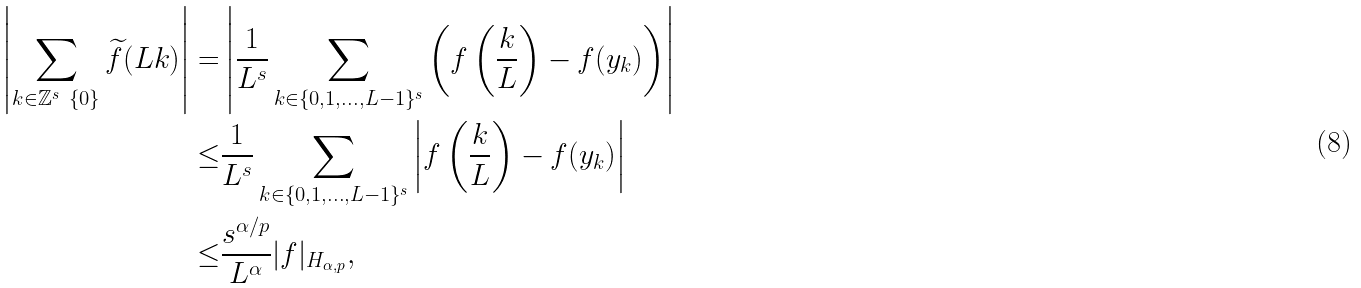<formula> <loc_0><loc_0><loc_500><loc_500>\left | \sum _ { k \in \mathbb { Z } ^ { s } \ \{ 0 \} } \widetilde { f } ( L k ) \right | = & \left | \frac { 1 } { L ^ { s } } \sum _ { k \in \{ 0 , 1 , \dots , L - 1 \} ^ { s } } \left ( f \left ( \frac { k } { L } \right ) - f ( y _ { k } ) \right ) \right | \\ \leq & \frac { 1 } { L ^ { s } } \sum _ { k \in \{ 0 , 1 , \dots , L - 1 \} ^ { s } } \left | f \left ( \frac { k } { L } \right ) - f ( y _ { k } ) \right | \\ \leq & \frac { s ^ { \alpha / p } } { L ^ { \alpha } } | f | _ { H _ { \alpha , p } } ,</formula> 